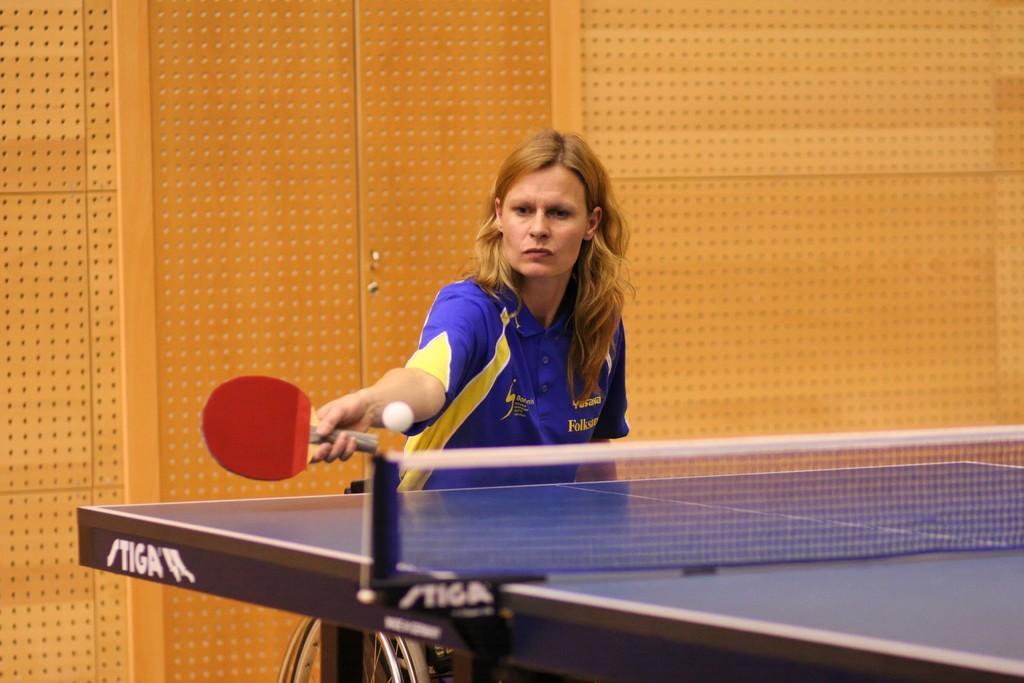In one or two sentences, can you explain what this image depicts? In this image I see a woman who is holding a bat and there is a table in front of her, I can also see there is a ball over here. In the background I see the wall. 